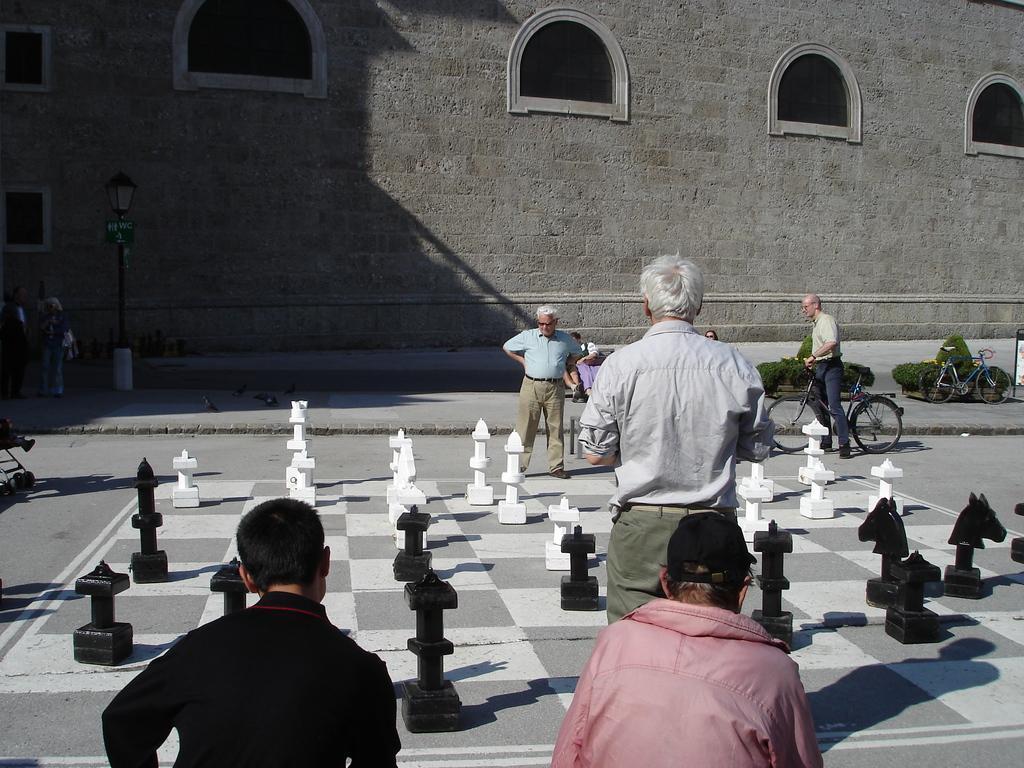How would you summarize this image in a sentence or two? In this picture there are some people those who are standing around the area which is printed with chess board, there is a building at the center side of the image and the people those are standing around the area are starting to chess board and there are some trees around the area. 